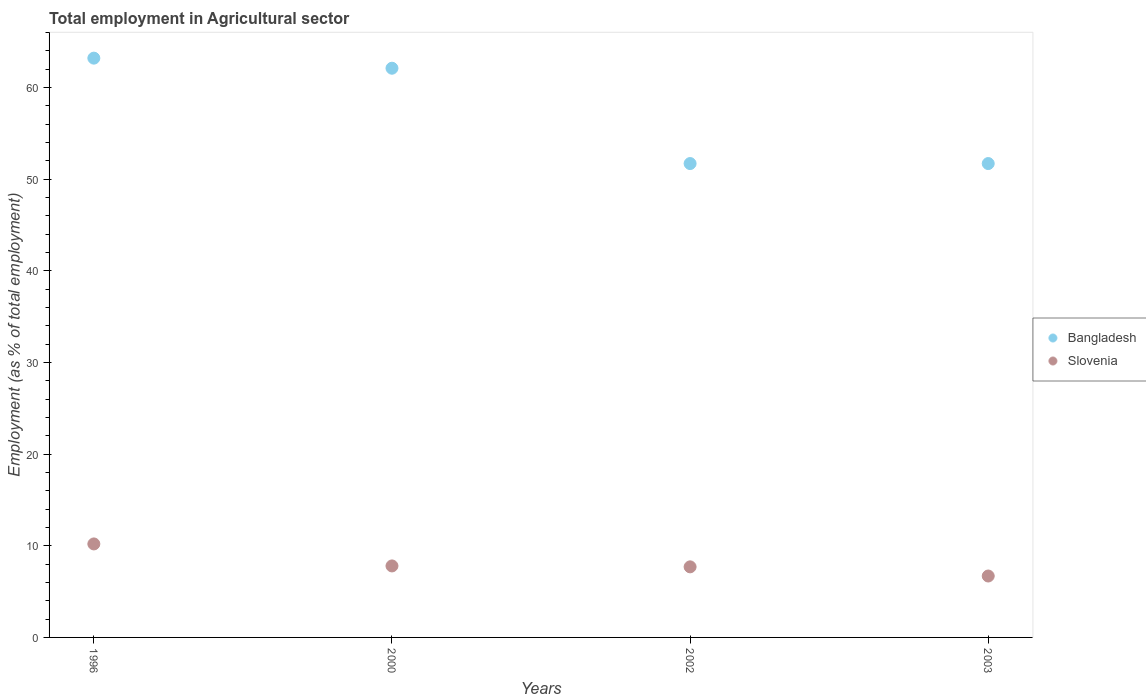Is the number of dotlines equal to the number of legend labels?
Keep it short and to the point. Yes. What is the employment in agricultural sector in Bangladesh in 2002?
Your answer should be compact. 51.7. Across all years, what is the maximum employment in agricultural sector in Slovenia?
Your response must be concise. 10.2. Across all years, what is the minimum employment in agricultural sector in Bangladesh?
Keep it short and to the point. 51.7. What is the total employment in agricultural sector in Slovenia in the graph?
Your answer should be very brief. 32.4. What is the difference between the employment in agricultural sector in Slovenia in 1996 and that in 2000?
Your answer should be compact. 2.4. What is the difference between the employment in agricultural sector in Slovenia in 2003 and the employment in agricultural sector in Bangladesh in 1996?
Provide a succinct answer. -56.5. What is the average employment in agricultural sector in Slovenia per year?
Your response must be concise. 8.1. In the year 1996, what is the difference between the employment in agricultural sector in Bangladesh and employment in agricultural sector in Slovenia?
Your answer should be very brief. 53. What is the ratio of the employment in agricultural sector in Slovenia in 1996 to that in 2002?
Keep it short and to the point. 1.32. What is the difference between the highest and the second highest employment in agricultural sector in Bangladesh?
Offer a terse response. 1.1. What is the difference between the highest and the lowest employment in agricultural sector in Bangladesh?
Your answer should be compact. 11.5. Is the sum of the employment in agricultural sector in Slovenia in 2000 and 2003 greater than the maximum employment in agricultural sector in Bangladesh across all years?
Make the answer very short. No. Does the employment in agricultural sector in Bangladesh monotonically increase over the years?
Offer a terse response. No. Is the employment in agricultural sector in Bangladesh strictly greater than the employment in agricultural sector in Slovenia over the years?
Offer a very short reply. Yes. Is the employment in agricultural sector in Bangladesh strictly less than the employment in agricultural sector in Slovenia over the years?
Offer a very short reply. No. How many dotlines are there?
Your response must be concise. 2. What is the difference between two consecutive major ticks on the Y-axis?
Give a very brief answer. 10. Does the graph contain grids?
Your response must be concise. No. Where does the legend appear in the graph?
Your answer should be compact. Center right. How many legend labels are there?
Provide a succinct answer. 2. How are the legend labels stacked?
Your answer should be compact. Vertical. What is the title of the graph?
Make the answer very short. Total employment in Agricultural sector. Does "Serbia" appear as one of the legend labels in the graph?
Your answer should be very brief. No. What is the label or title of the X-axis?
Provide a short and direct response. Years. What is the label or title of the Y-axis?
Offer a terse response. Employment (as % of total employment). What is the Employment (as % of total employment) in Bangladesh in 1996?
Offer a very short reply. 63.2. What is the Employment (as % of total employment) of Slovenia in 1996?
Provide a short and direct response. 10.2. What is the Employment (as % of total employment) of Bangladesh in 2000?
Ensure brevity in your answer.  62.1. What is the Employment (as % of total employment) of Slovenia in 2000?
Offer a very short reply. 7.8. What is the Employment (as % of total employment) of Bangladesh in 2002?
Your answer should be compact. 51.7. What is the Employment (as % of total employment) of Slovenia in 2002?
Your answer should be very brief. 7.7. What is the Employment (as % of total employment) in Bangladesh in 2003?
Keep it short and to the point. 51.7. What is the Employment (as % of total employment) in Slovenia in 2003?
Make the answer very short. 6.7. Across all years, what is the maximum Employment (as % of total employment) of Bangladesh?
Offer a very short reply. 63.2. Across all years, what is the maximum Employment (as % of total employment) in Slovenia?
Your response must be concise. 10.2. Across all years, what is the minimum Employment (as % of total employment) of Bangladesh?
Give a very brief answer. 51.7. Across all years, what is the minimum Employment (as % of total employment) of Slovenia?
Your response must be concise. 6.7. What is the total Employment (as % of total employment) in Bangladesh in the graph?
Provide a succinct answer. 228.7. What is the total Employment (as % of total employment) in Slovenia in the graph?
Provide a succinct answer. 32.4. What is the difference between the Employment (as % of total employment) in Bangladesh in 1996 and that in 2000?
Ensure brevity in your answer.  1.1. What is the difference between the Employment (as % of total employment) in Slovenia in 1996 and that in 2000?
Your response must be concise. 2.4. What is the difference between the Employment (as % of total employment) in Slovenia in 1996 and that in 2003?
Offer a very short reply. 3.5. What is the difference between the Employment (as % of total employment) of Bangladesh in 2000 and that in 2002?
Provide a succinct answer. 10.4. What is the difference between the Employment (as % of total employment) of Slovenia in 2000 and that in 2002?
Your answer should be very brief. 0.1. What is the difference between the Employment (as % of total employment) in Bangladesh in 2000 and that in 2003?
Your answer should be very brief. 10.4. What is the difference between the Employment (as % of total employment) in Slovenia in 2002 and that in 2003?
Give a very brief answer. 1. What is the difference between the Employment (as % of total employment) of Bangladesh in 1996 and the Employment (as % of total employment) of Slovenia in 2000?
Your answer should be compact. 55.4. What is the difference between the Employment (as % of total employment) in Bangladesh in 1996 and the Employment (as % of total employment) in Slovenia in 2002?
Make the answer very short. 55.5. What is the difference between the Employment (as % of total employment) in Bangladesh in 1996 and the Employment (as % of total employment) in Slovenia in 2003?
Ensure brevity in your answer.  56.5. What is the difference between the Employment (as % of total employment) of Bangladesh in 2000 and the Employment (as % of total employment) of Slovenia in 2002?
Keep it short and to the point. 54.4. What is the difference between the Employment (as % of total employment) of Bangladesh in 2000 and the Employment (as % of total employment) of Slovenia in 2003?
Make the answer very short. 55.4. What is the average Employment (as % of total employment) in Bangladesh per year?
Provide a short and direct response. 57.17. In the year 1996, what is the difference between the Employment (as % of total employment) of Bangladesh and Employment (as % of total employment) of Slovenia?
Keep it short and to the point. 53. In the year 2000, what is the difference between the Employment (as % of total employment) of Bangladesh and Employment (as % of total employment) of Slovenia?
Ensure brevity in your answer.  54.3. In the year 2003, what is the difference between the Employment (as % of total employment) of Bangladesh and Employment (as % of total employment) of Slovenia?
Provide a short and direct response. 45. What is the ratio of the Employment (as % of total employment) of Bangladesh in 1996 to that in 2000?
Your answer should be compact. 1.02. What is the ratio of the Employment (as % of total employment) of Slovenia in 1996 to that in 2000?
Provide a short and direct response. 1.31. What is the ratio of the Employment (as % of total employment) of Bangladesh in 1996 to that in 2002?
Offer a very short reply. 1.22. What is the ratio of the Employment (as % of total employment) of Slovenia in 1996 to that in 2002?
Make the answer very short. 1.32. What is the ratio of the Employment (as % of total employment) in Bangladesh in 1996 to that in 2003?
Make the answer very short. 1.22. What is the ratio of the Employment (as % of total employment) of Slovenia in 1996 to that in 2003?
Give a very brief answer. 1.52. What is the ratio of the Employment (as % of total employment) of Bangladesh in 2000 to that in 2002?
Your answer should be compact. 1.2. What is the ratio of the Employment (as % of total employment) in Slovenia in 2000 to that in 2002?
Ensure brevity in your answer.  1.01. What is the ratio of the Employment (as % of total employment) of Bangladesh in 2000 to that in 2003?
Your answer should be compact. 1.2. What is the ratio of the Employment (as % of total employment) in Slovenia in 2000 to that in 2003?
Keep it short and to the point. 1.16. What is the ratio of the Employment (as % of total employment) in Bangladesh in 2002 to that in 2003?
Offer a very short reply. 1. What is the ratio of the Employment (as % of total employment) of Slovenia in 2002 to that in 2003?
Your response must be concise. 1.15. What is the difference between the highest and the lowest Employment (as % of total employment) in Bangladesh?
Your response must be concise. 11.5. 